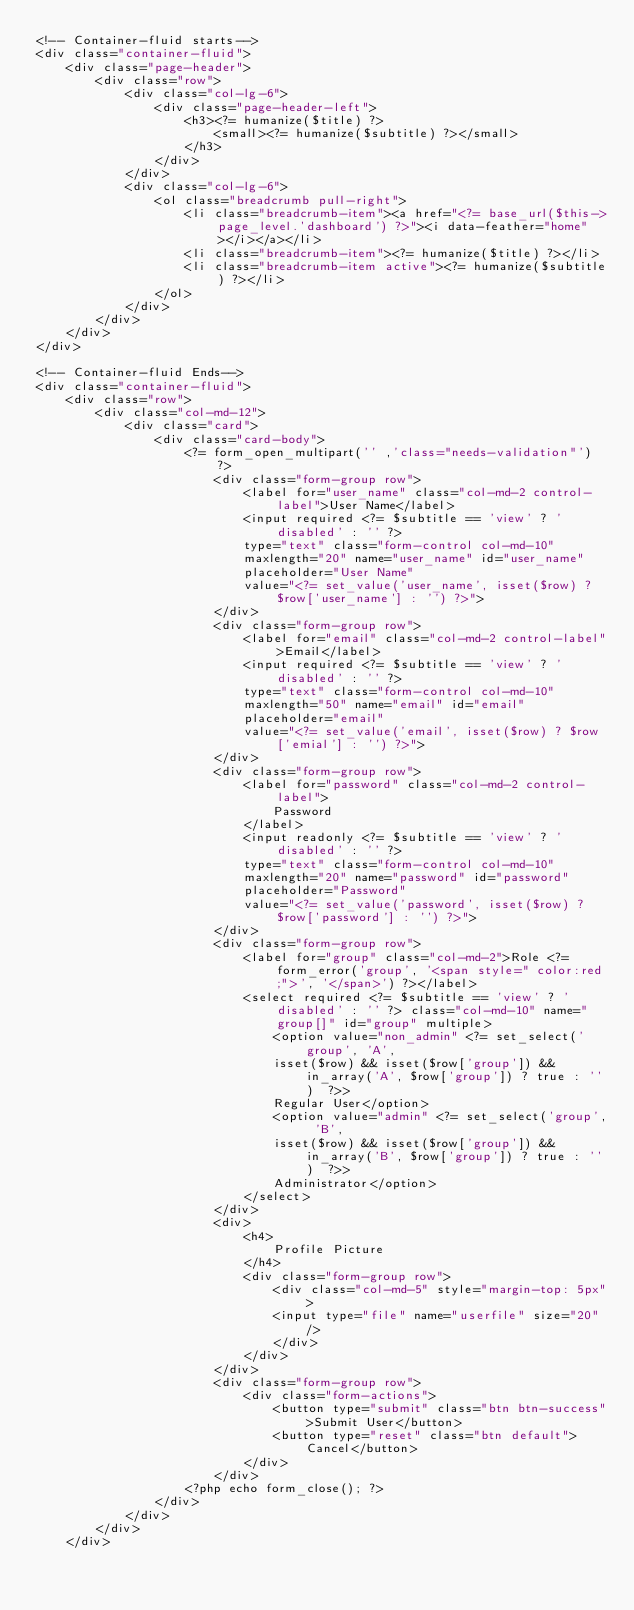<code> <loc_0><loc_0><loc_500><loc_500><_PHP_><!-- Container-fluid starts-->
<div class="container-fluid">
    <div class="page-header">
        <div class="row">
            <div class="col-lg-6">
                <div class="page-header-left">
                    <h3><?= humanize($title) ?>
                        <small><?= humanize($subtitle) ?></small>
                    </h3>
                </div>
            </div>
            <div class="col-lg-6">
                <ol class="breadcrumb pull-right">
                    <li class="breadcrumb-item"><a href="<?= base_url($this->page_level.'dashboard') ?>"><i data-feather="home"></i></a></li>
                    <li class="breadcrumb-item"><?= humanize($title) ?></li>
                    <li class="breadcrumb-item active"><?= humanize($subtitle) ?></li>
                </ol>
            </div>
        </div>
    </div>
</div>

<!-- Container-fluid Ends-->
<div class="container-fluid">
    <div class="row">
        <div class="col-md-12">
            <div class="card">
                <div class="card-body">
                    <?= form_open_multipart('' ,'class="needs-validation"') ?>
                        <div class="form-group row">
                            <label for="user_name" class="col-md-2 control-label">User Name</label>
                            <input required <?= $subtitle == 'view' ? 'disabled' : '' ?> 
                            type="text" class="form-control col-md-10" 
                            maxlength="20" name="user_name" id="user_name" 
                            placeholder="User Name"
                            value="<?= set_value('user_name', isset($row) ? $row['user_name'] : '') ?>">
                        </div>
                        <div class="form-group row">
                            <label for="email" class="col-md-2 control-label">Email</label>
                            <input required <?= $subtitle == 'view' ? 'disabled' : '' ?> 
                            type="text" class="form-control col-md-10" 
                            maxlength="50" name="email" id="email" 
                            placeholder="email"
                            value="<?= set_value('email', isset($row) ? $row['emial'] : '') ?>">
                        </div>
                        <div class="form-group row">
                            <label for="password" class="col-md-2 control-label">
                                Password
                            </label>
                            <input readonly <?= $subtitle == 'view' ? 'disabled' : '' ?> 
                            type="text" class="form-control col-md-10" 
                            maxlength="20" name="password" id="password" 
                            placeholder="Password"
                            value="<?= set_value('password', isset($row) ? $row['password'] : '') ?>">
                        </div>
                        <div class="form-group row">
                            <label for="group" class="col-md-2">Role <?= form_error('group', '<span style=" color:red;">', '</span>') ?></label>
                            <select required <?= $subtitle == 'view' ? 'disabled' : '' ?> class="col-md-10" name="group[]" id="group" multiple>
                                <option value="non_admin" <?= set_select('group', 'A', 
                                isset($row) && isset($row['group']) && in_array('A', $row['group']) ? true : '')  ?>>
                                Regular User</option>
                                <option value="admin" <?= set_select('group', 'B', 
                                isset($row) && isset($row['group']) && in_array('B', $row['group']) ? true : '')  ?>>
                                Administrator</option> 
                            </select>
                        </div>
                        <div>
                            <h4>
                                Profile Picture
                            </h4>
                            <div class="form-group row">
                                <div class="col-md-5" style="margin-top: 5px">
                                <input type="file" name="userfile" size="20" />
                                </div>
                            </div>
                        </div>
                        <div class="form-group row">
                            <div class="form-actions">
                                <button type="submit" class="btn btn-success">Submit User</button>
                                <button type="reset" class="btn default">Cancel</button>
                            </div>
                        </div>
                    <?php echo form_close(); ?>
                </div>
            </div>
        </div>
    </div></code> 